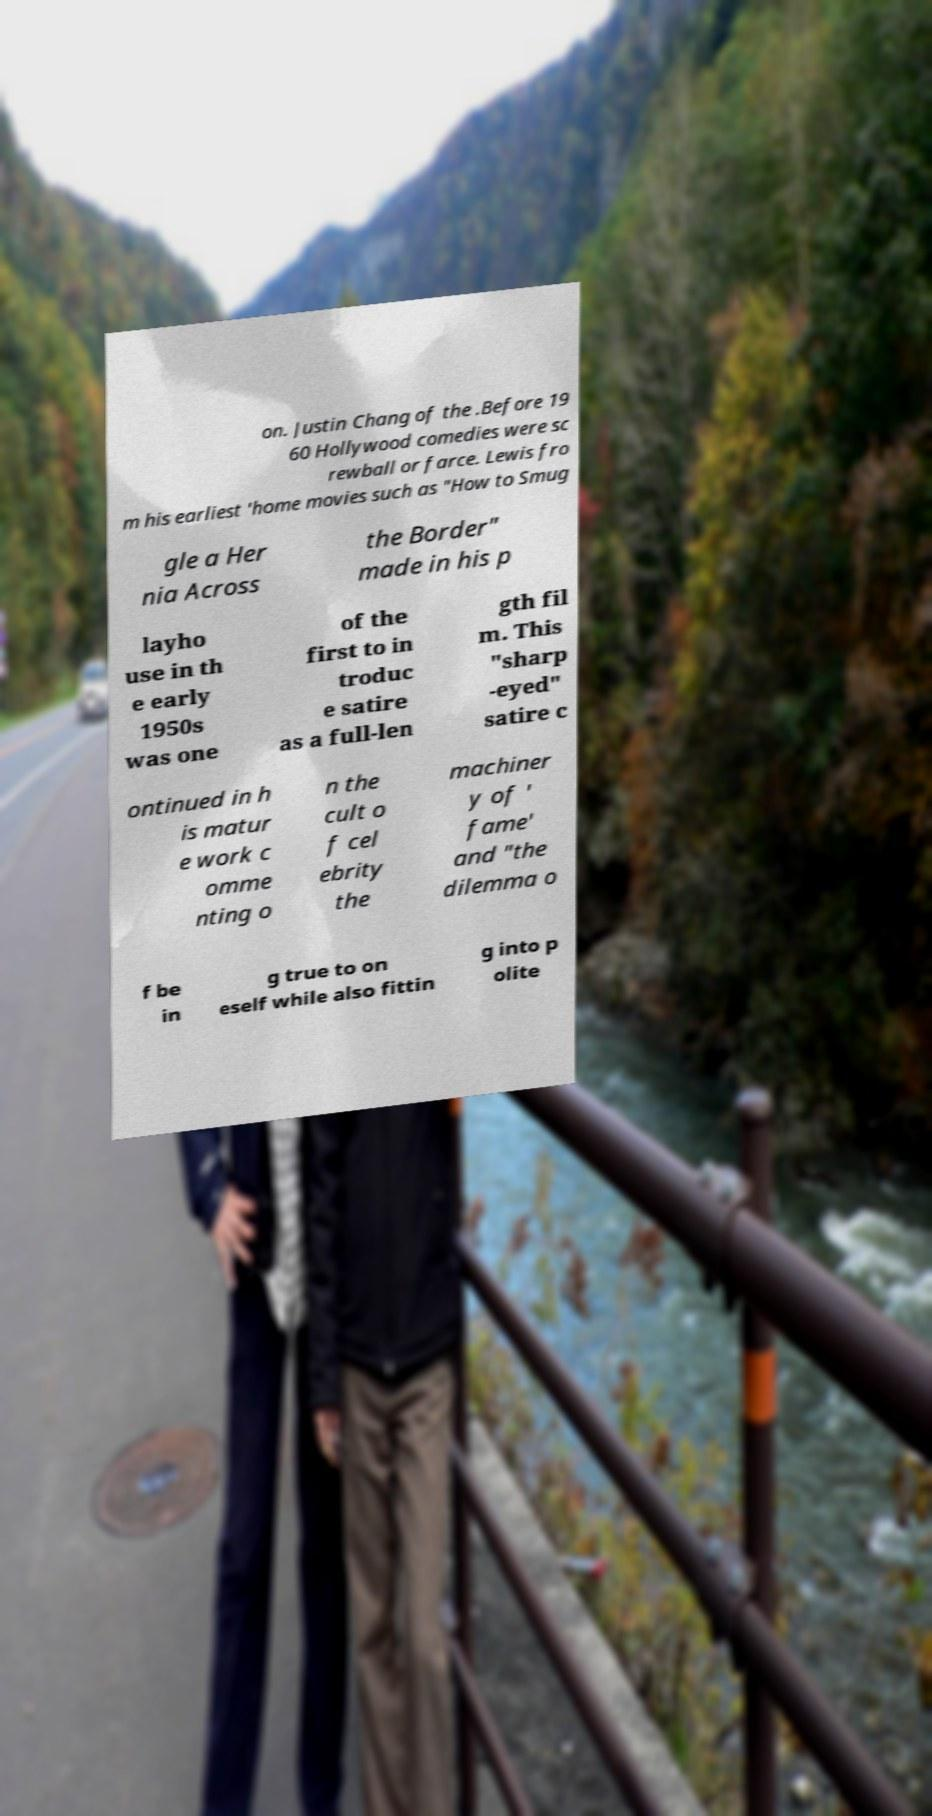Can you accurately transcribe the text from the provided image for me? on. Justin Chang of the .Before 19 60 Hollywood comedies were sc rewball or farce. Lewis fro m his earliest 'home movies such as "How to Smug gle a Her nia Across the Border" made in his p layho use in th e early 1950s was one of the first to in troduc e satire as a full-len gth fil m. This "sharp -eyed" satire c ontinued in h is matur e work c omme nting o n the cult o f cel ebrity the machiner y of ' fame' and "the dilemma o f be in g true to on eself while also fittin g into p olite 